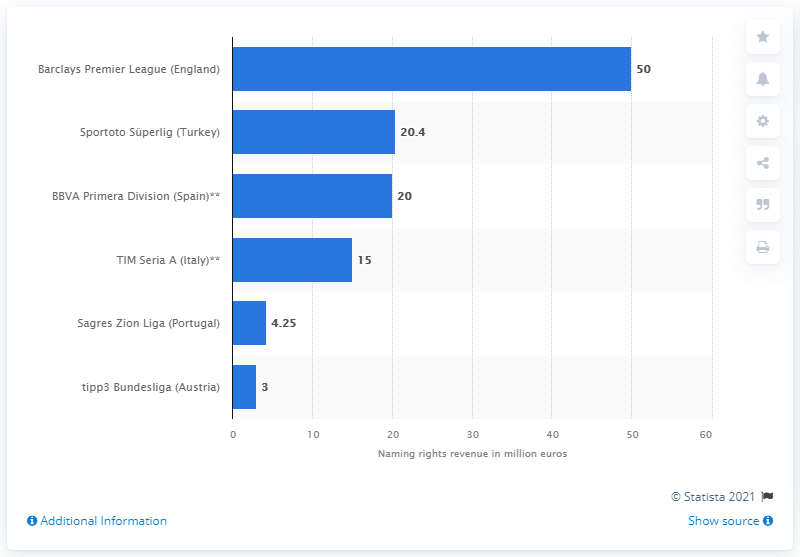Give some essential details in this illustration. Barclays pays $50 million per season for the naming rights to the Barclays Premier League. 